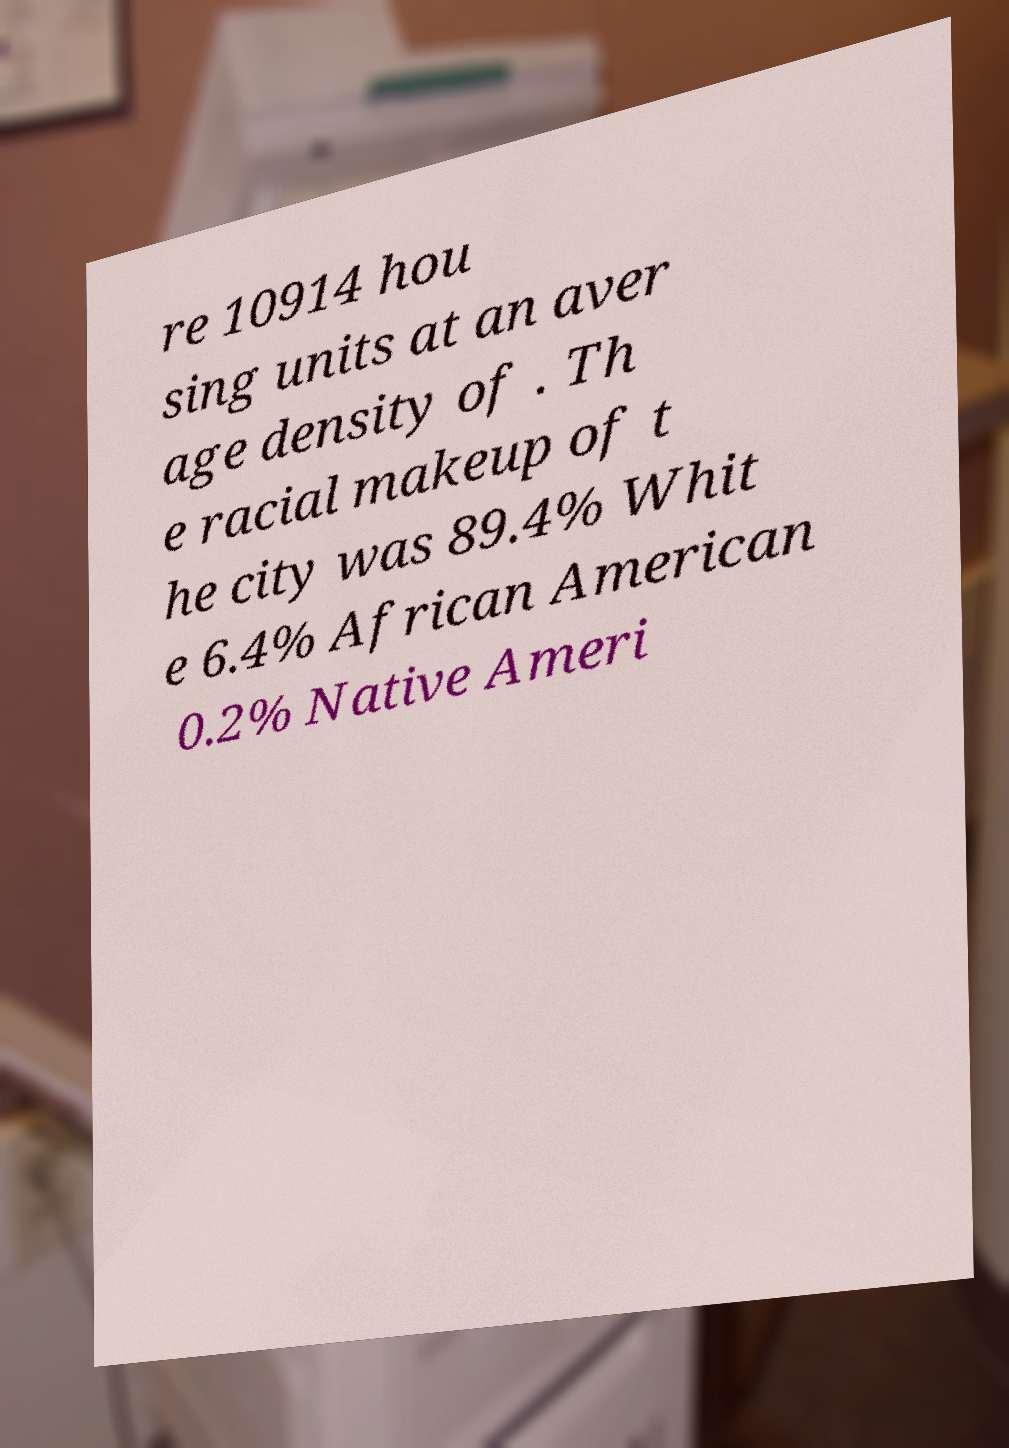Could you assist in decoding the text presented in this image and type it out clearly? re 10914 hou sing units at an aver age density of . Th e racial makeup of t he city was 89.4% Whit e 6.4% African American 0.2% Native Ameri 